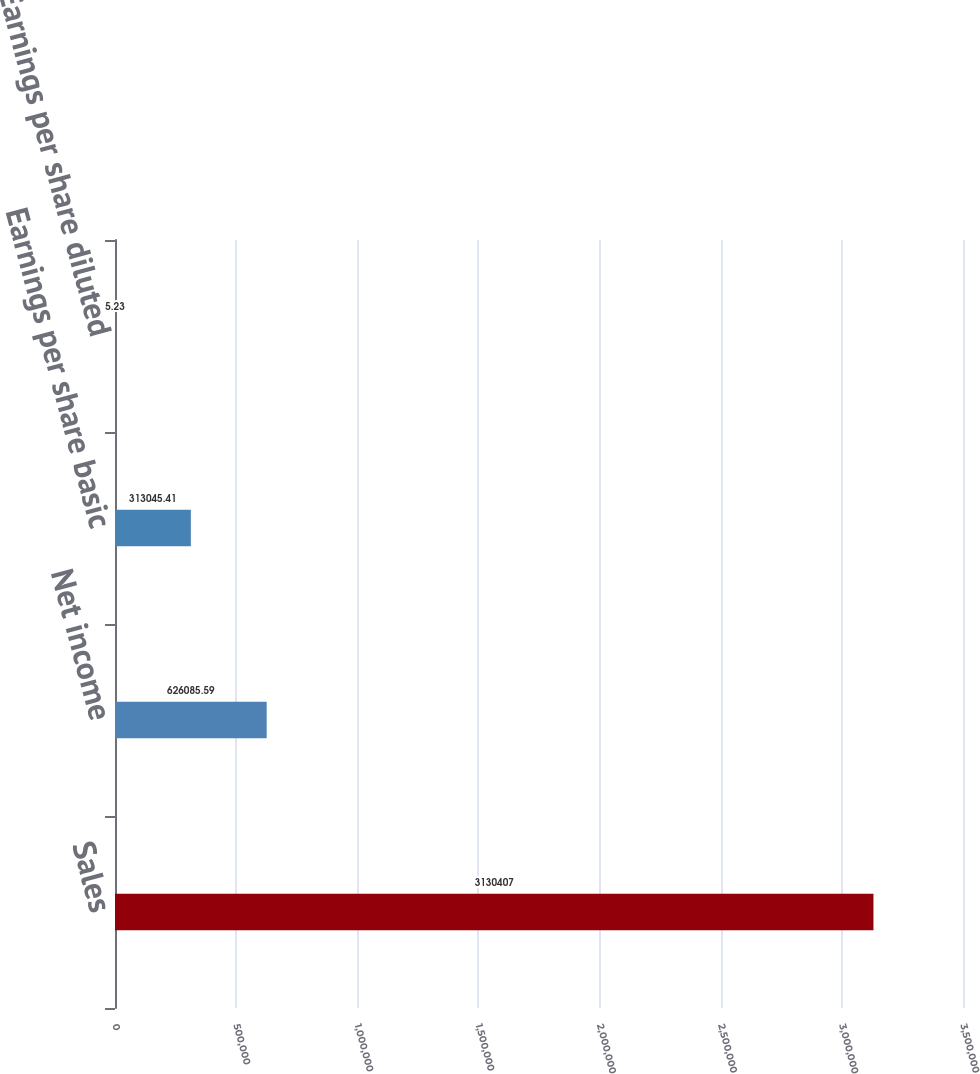Convert chart to OTSL. <chart><loc_0><loc_0><loc_500><loc_500><bar_chart><fcel>Sales<fcel>Net income<fcel>Earnings per share basic<fcel>Earnings per share diluted<nl><fcel>3.13041e+06<fcel>626086<fcel>313045<fcel>5.23<nl></chart> 